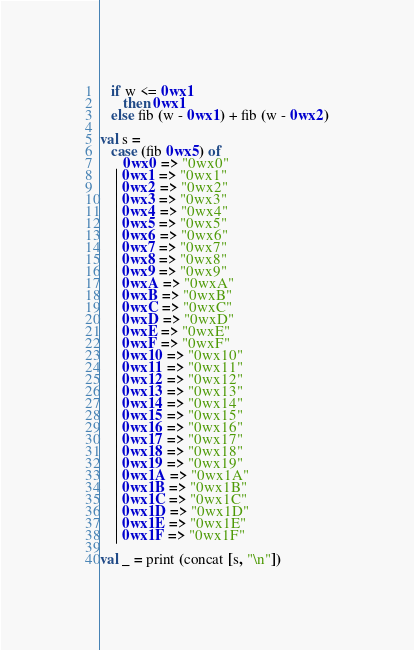Convert code to text. <code><loc_0><loc_0><loc_500><loc_500><_SML_>   if w <= 0wx1
      then 0wx1
   else fib (w - 0wx1) + fib (w - 0wx2)

val s =
   case (fib 0wx5) of
      0wx0 => "0wx0"
    | 0wx1 => "0wx1"
    | 0wx2 => "0wx2"
    | 0wx3 => "0wx3"
    | 0wx4 => "0wx4"
    | 0wx5 => "0wx5"
    | 0wx6 => "0wx6"
    | 0wx7 => "0wx7"
    | 0wx8 => "0wx8"
    | 0wx9 => "0wx9"
    | 0wxA => "0wxA"
    | 0wxB => "0wxB"
    | 0wxC => "0wxC"
    | 0wxD => "0wxD"
    | 0wxE => "0wxE"
    | 0wxF => "0wxF"
    | 0wx10 => "0wx10"
    | 0wx11 => "0wx11"
    | 0wx12 => "0wx12"
    | 0wx13 => "0wx13"
    | 0wx14 => "0wx14"
    | 0wx15 => "0wx15"
    | 0wx16 => "0wx16"
    | 0wx17 => "0wx17"
    | 0wx18 => "0wx18"
    | 0wx19 => "0wx19"
    | 0wx1A => "0wx1A"
    | 0wx1B => "0wx1B"
    | 0wx1C => "0wx1C"
    | 0wx1D => "0wx1D"
    | 0wx1E => "0wx1E"
    | 0wx1F => "0wx1F"

val _ = print (concat [s, "\n"])
</code> 